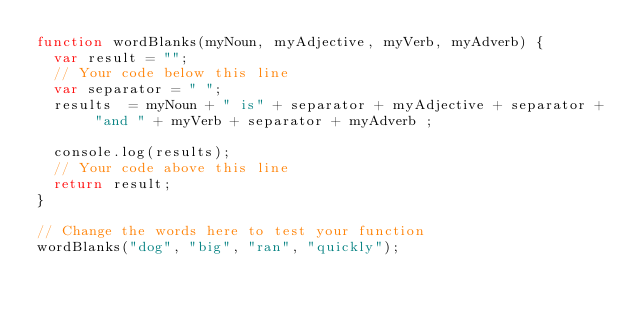Convert code to text. <code><loc_0><loc_0><loc_500><loc_500><_JavaScript_>function wordBlanks(myNoun, myAdjective, myVerb, myAdverb) {
  var result = "";
  // Your code below this line
  var separator = " ";
  results  = myNoun + " is" + separator + myAdjective + separator + "and " + myVerb + separator + myAdverb ;

  console.log(results);
  // Your code above this line
  return result;
}

// Change the words here to test your function
wordBlanks("dog", "big", "ran", "quickly");
</code> 